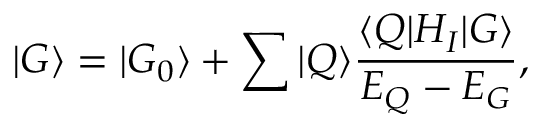Convert formula to latex. <formula><loc_0><loc_0><loc_500><loc_500>| G \rangle = | G _ { 0 } \rangle + \sum | Q \rangle \frac { \langle Q | H _ { I } | G \rangle } { E _ { Q } - E _ { G } } ,</formula> 